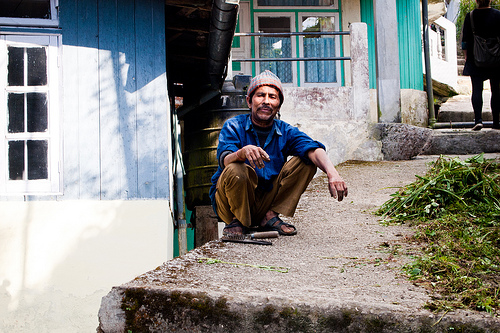<image>
Is there a debris in front of the person? Yes. The debris is positioned in front of the person, appearing closer to the camera viewpoint. 